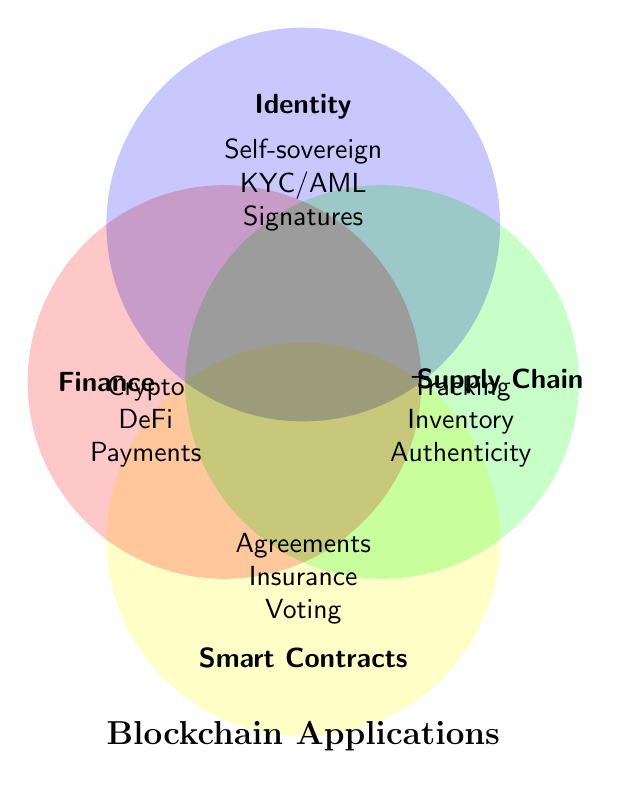What are the four main categories in the figure? The figure shows four intersecting circles, each labeled with a different category. These labels identify the categories present.
Answer: Finance, Supply Chain, Identity, Smart Contracts Which applications belong to the Finance category? The label "Finance" indicates a circle, inside which there are applications listed as Crypto, DeFi, and Payments.
Answer: Crypto, DeFi, Payments How many applications does the Identity category have? The "Identity" circle contains three entries: Self-sovereign, KYC/AML, and Signatures.
Answer: 3 Which category has "Voting systems" as an application? The application "Voting systems" is found inside the circle labeled "Smart Contracts".
Answer: Smart Contracts Which two categories have overlapping applications? The figure doesn't show any overlapping regions between the circles, which means no applications are shared between categories.
Answer: None Are there any applications related to Insurance claims? If yes, what is the category? The application "Insurance claims" is located within the "Smart Contracts" circle.
Answer: Yes, Smart Contracts What is the total number of unique applications listed across all categories? Counting all the applications listed independently under each of the four categories: Finance (3), Supply Chain (3), Identity (3), Smart Contracts (3). Adding these gives 3+3+3+3=12.
Answer: 12 Compare the applications related to Identity and Finance categories. Which has more? Both the Identity and Finance categories have exactly three applications listed under them.
Answer: Equal Which categories are closest to each other in the diagram? The Finance and Supply Chain circles intersect at the middle of the figure, making them the closest to each other.
Answer: Finance and Supply Chain 